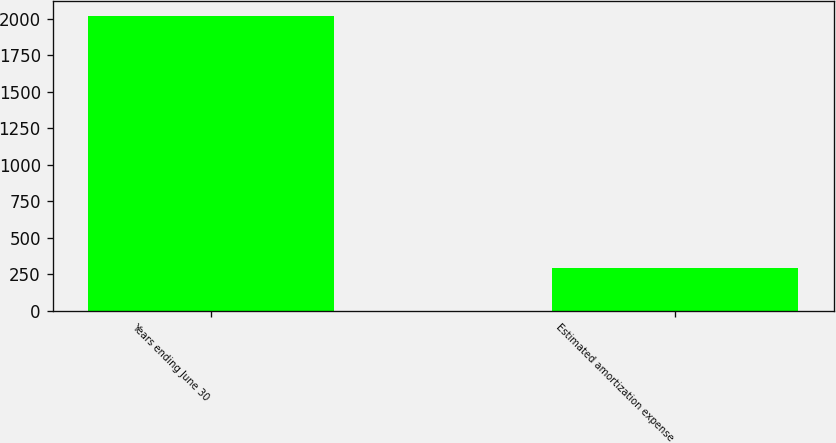<chart> <loc_0><loc_0><loc_500><loc_500><bar_chart><fcel>Years ending June 30<fcel>Estimated amortization expense<nl><fcel>2018<fcel>292<nl></chart> 